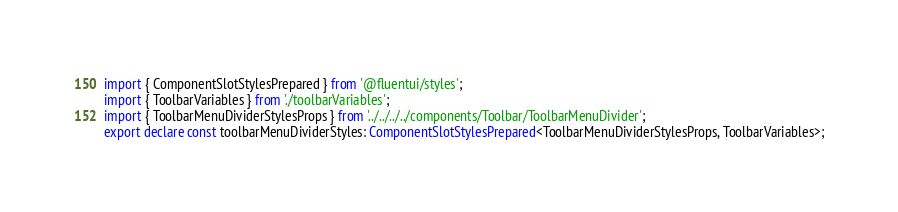<code> <loc_0><loc_0><loc_500><loc_500><_TypeScript_>import { ComponentSlotStylesPrepared } from '@fluentui/styles';
import { ToolbarVariables } from './toolbarVariables';
import { ToolbarMenuDividerStylesProps } from '../../../../components/Toolbar/ToolbarMenuDivider';
export declare const toolbarMenuDividerStyles: ComponentSlotStylesPrepared<ToolbarMenuDividerStylesProps, ToolbarVariables>;
</code> 